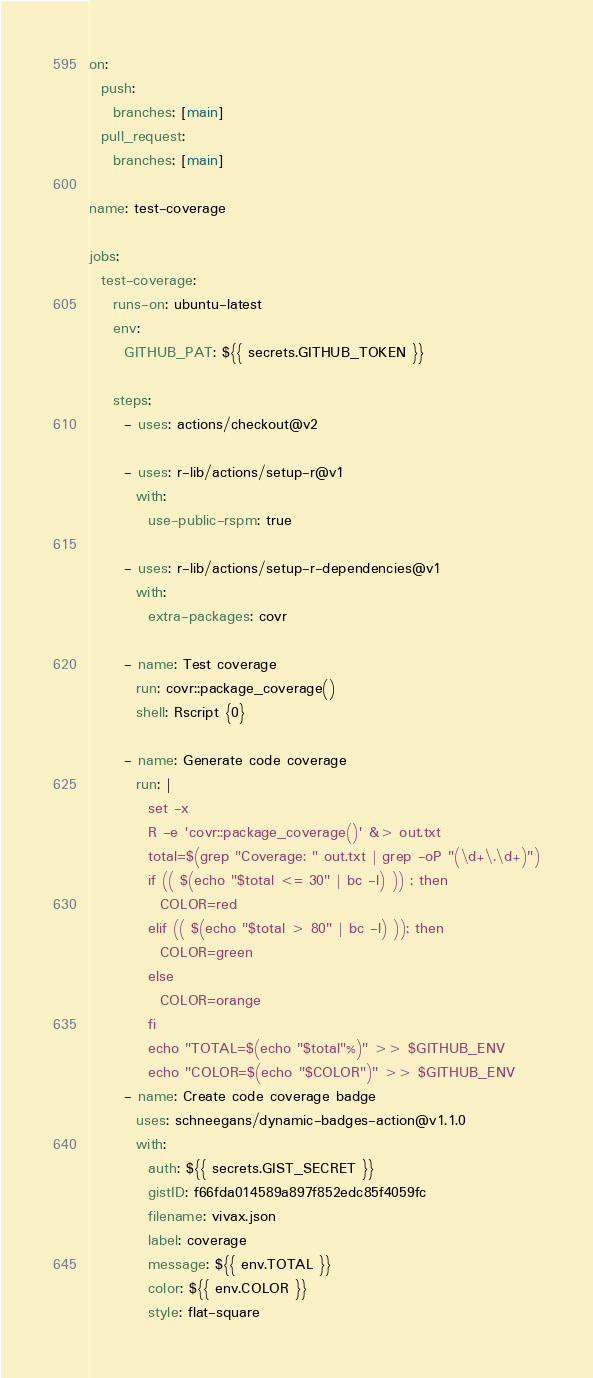Convert code to text. <code><loc_0><loc_0><loc_500><loc_500><_YAML_>on:
  push:
    branches: [main]
  pull_request:
    branches: [main]

name: test-coverage

jobs:
  test-coverage:
    runs-on: ubuntu-latest
    env:
      GITHUB_PAT: ${{ secrets.GITHUB_TOKEN }}

    steps:
      - uses: actions/checkout@v2

      - uses: r-lib/actions/setup-r@v1
        with:
          use-public-rspm: true

      - uses: r-lib/actions/setup-r-dependencies@v1
        with:
          extra-packages: covr

      - name: Test coverage
        run: covr::package_coverage()
        shell: Rscript {0}

      - name: Generate code coverage
        run: |
          set -x
          R -e 'covr::package_coverage()' &> out.txt
          total=$(grep "Coverage: " out.txt | grep -oP "(\d+\.\d+)")
          if (( $(echo "$total <= 30" | bc -l) )) ; then
            COLOR=red
          elif (( $(echo "$total > 80" | bc -l) )); then
            COLOR=green
          else
            COLOR=orange
          fi
          echo "TOTAL=$(echo "$total"%)" >> $GITHUB_ENV
          echo "COLOR=$(echo "$COLOR")" >> $GITHUB_ENV
      - name: Create code coverage badge
        uses: schneegans/dynamic-badges-action@v1.1.0
        with:
          auth: ${{ secrets.GIST_SECRET }}
          gistID: f66fda014589a897f852edc85f4059fc
          filename: vivax.json
          label: coverage
          message: ${{ env.TOTAL }}
          color: ${{ env.COLOR }}
          style: flat-square
</code> 